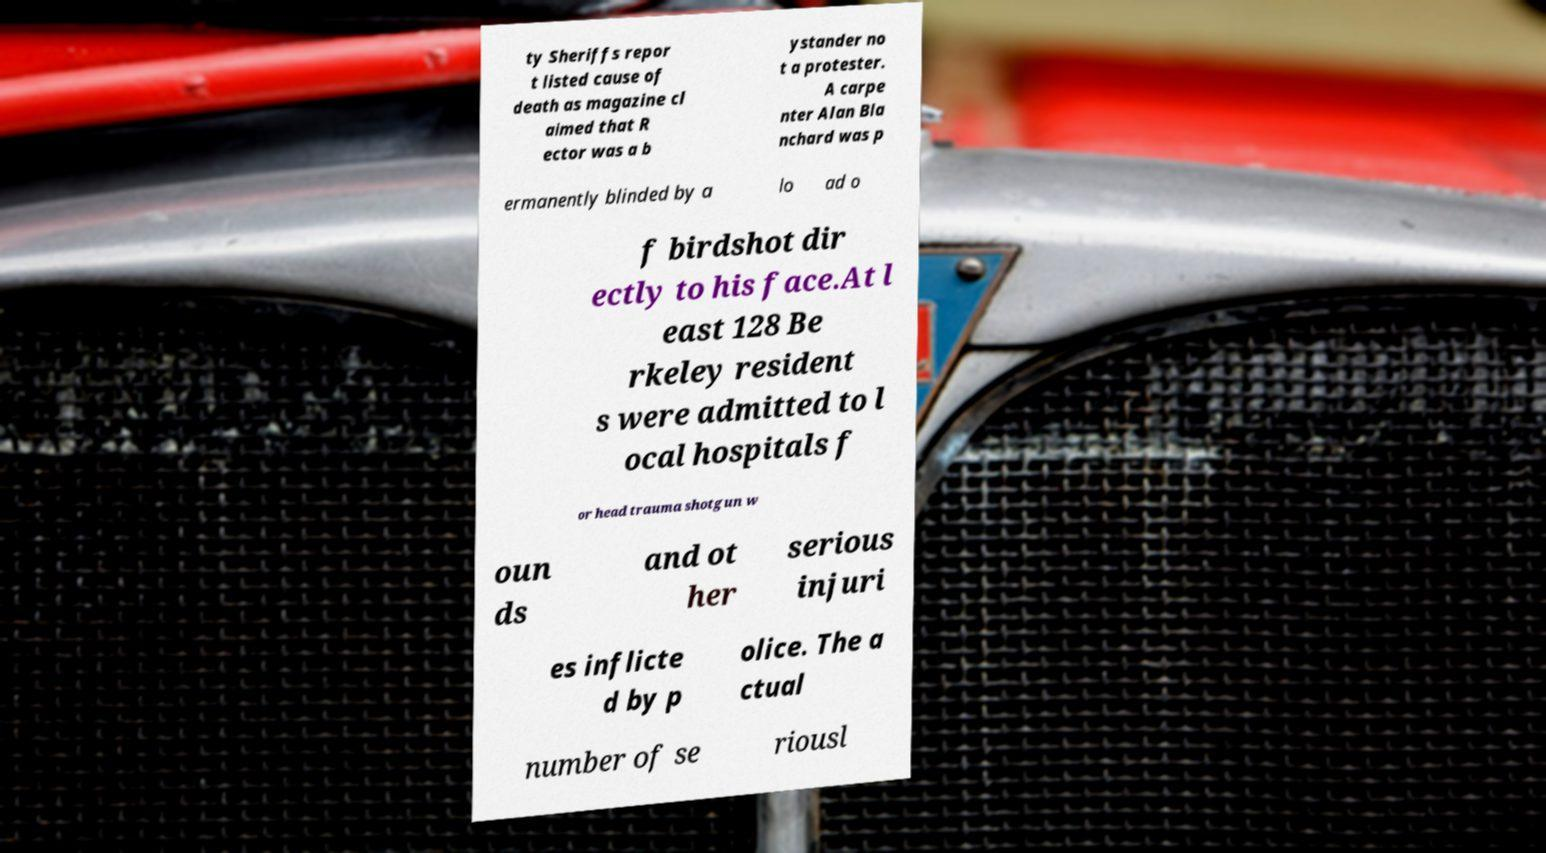Can you read and provide the text displayed in the image?This photo seems to have some interesting text. Can you extract and type it out for me? ty Sheriffs repor t listed cause of death as magazine cl aimed that R ector was a b ystander no t a protester. A carpe nter Alan Bla nchard was p ermanently blinded by a lo ad o f birdshot dir ectly to his face.At l east 128 Be rkeley resident s were admitted to l ocal hospitals f or head trauma shotgun w oun ds and ot her serious injuri es inflicte d by p olice. The a ctual number of se riousl 